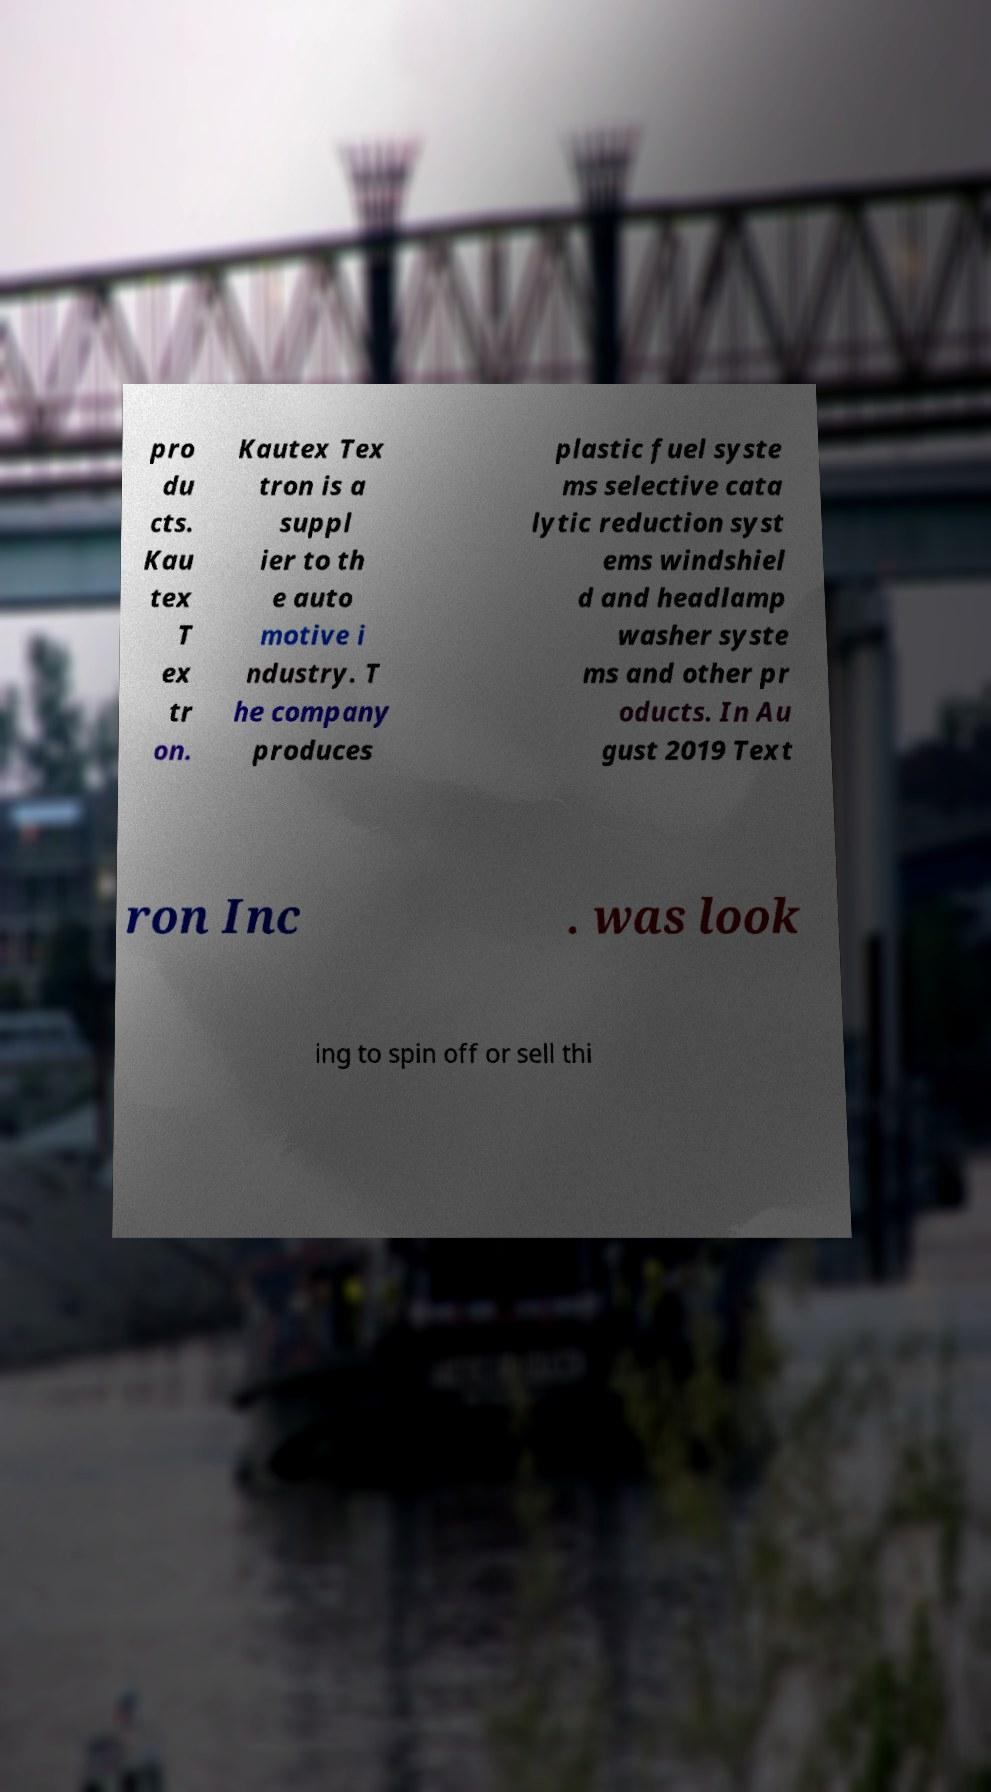What messages or text are displayed in this image? I need them in a readable, typed format. pro du cts. Kau tex T ex tr on. Kautex Tex tron is a suppl ier to th e auto motive i ndustry. T he company produces plastic fuel syste ms selective cata lytic reduction syst ems windshiel d and headlamp washer syste ms and other pr oducts. In Au gust 2019 Text ron Inc . was look ing to spin off or sell thi 